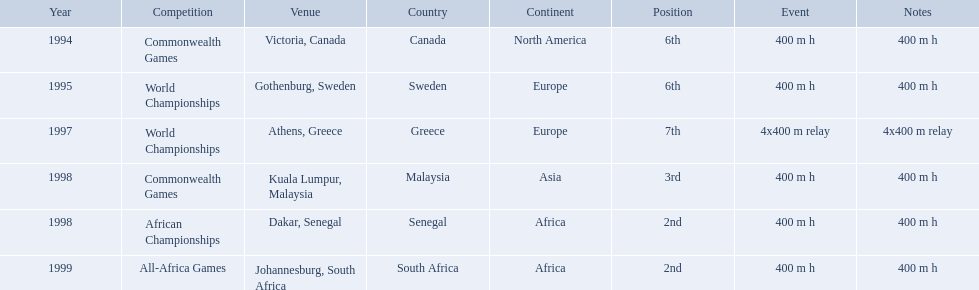What races did ken harden run? 400 m h, 400 m h, 4x400 m relay, 400 m h, 400 m h, 400 m h. Which race did ken harden run in 1997? 4x400 m relay. What years did ken harder compete in? 1994, 1995, 1997, 1998, 1998, 1999. For the 1997 relay, what distance was ran? 4x400 m relay. 